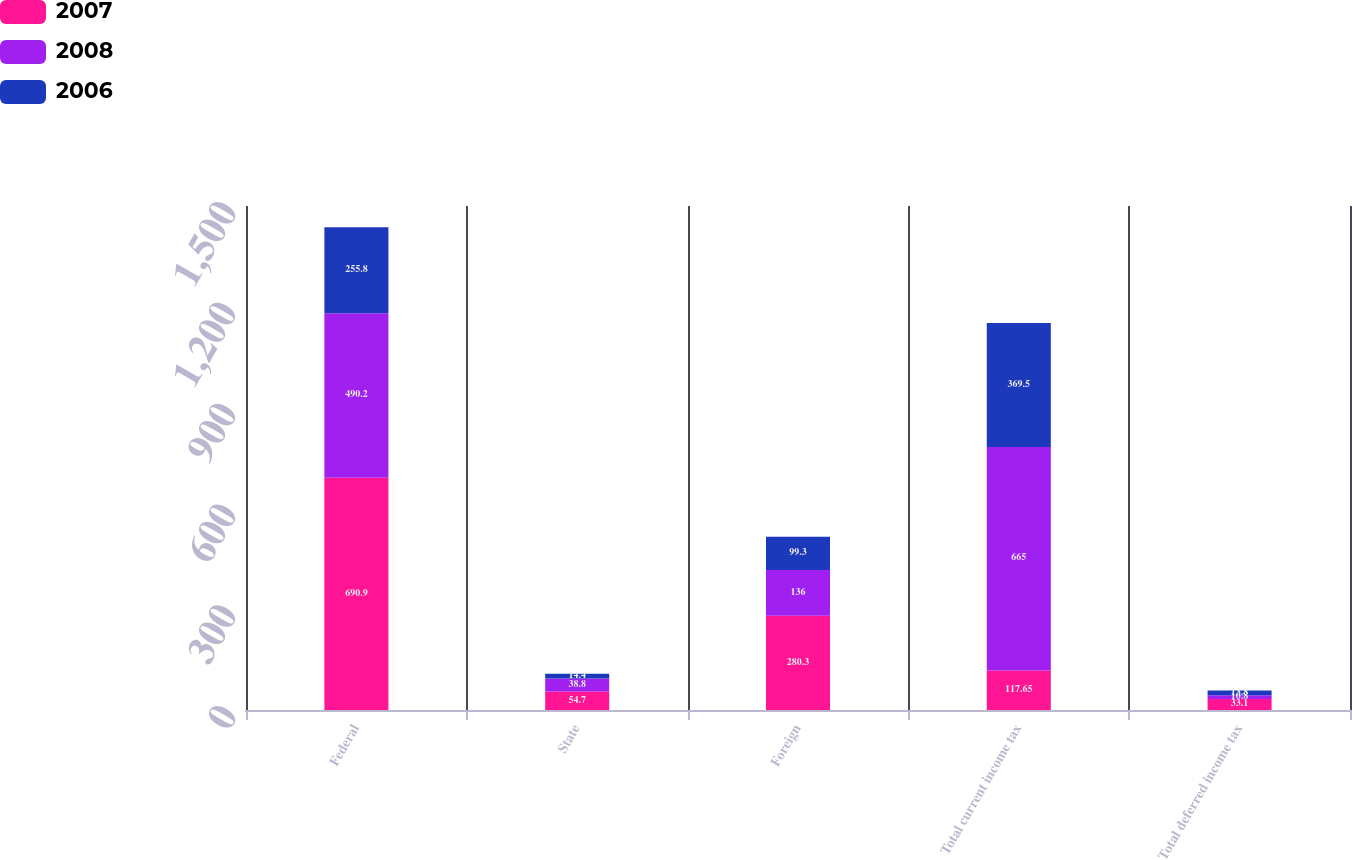Convert chart. <chart><loc_0><loc_0><loc_500><loc_500><stacked_bar_chart><ecel><fcel>Federal<fcel>State<fcel>Foreign<fcel>Total current income tax<fcel>Total deferred income tax<nl><fcel>2007<fcel>690.9<fcel>54.7<fcel>280.3<fcel>117.65<fcel>33.1<nl><fcel>2008<fcel>490.2<fcel>38.8<fcel>136<fcel>665<fcel>10.8<nl><fcel>2006<fcel>255.8<fcel>14.4<fcel>99.3<fcel>369.5<fcel>13.8<nl></chart> 